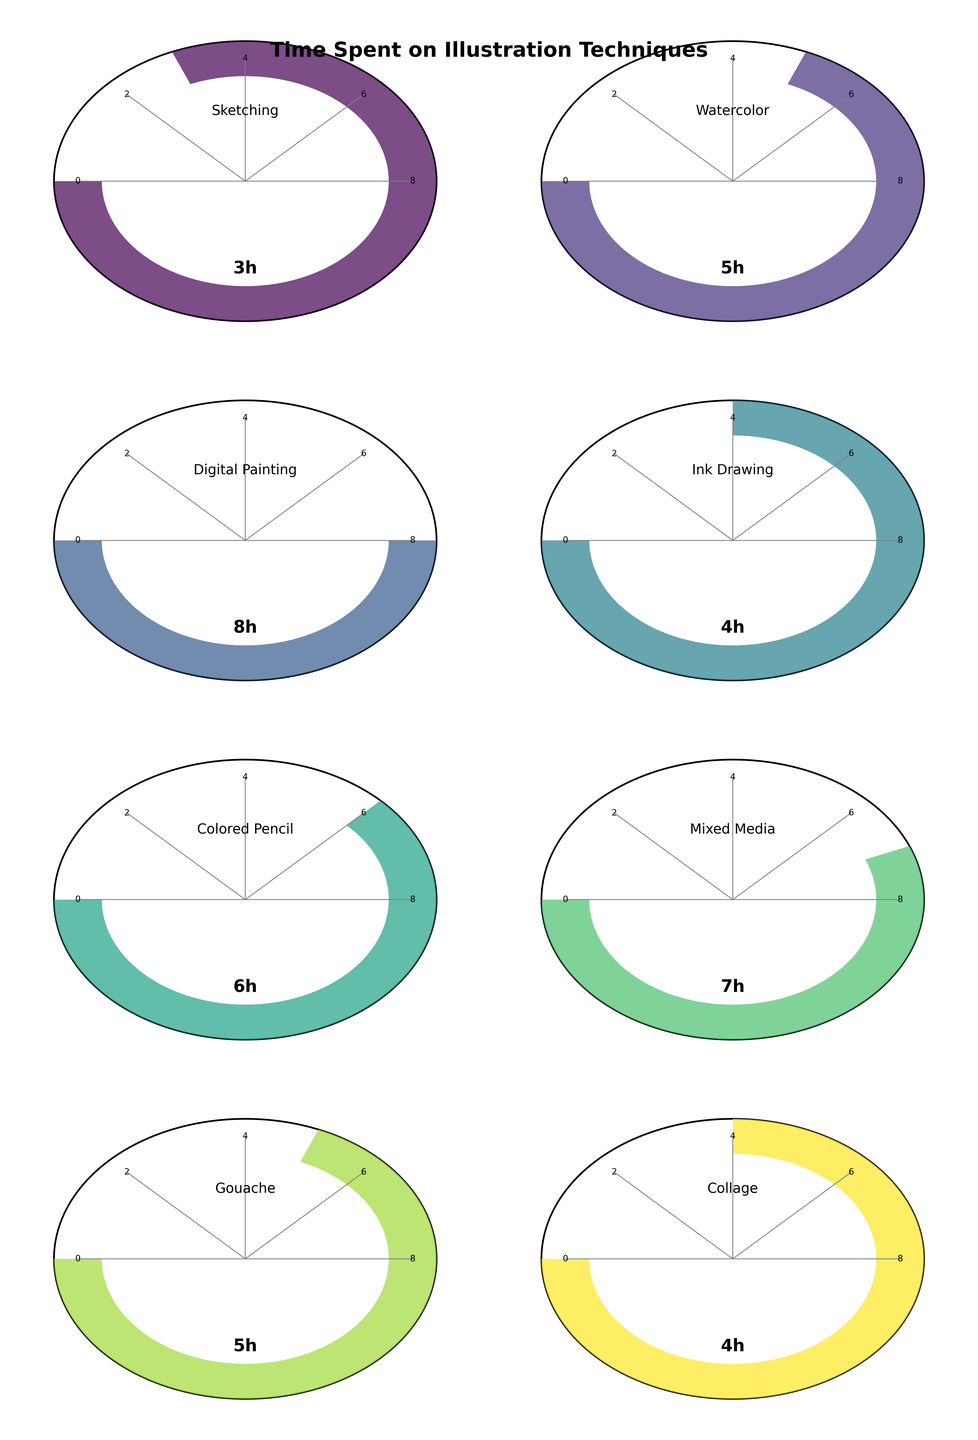What is the title of the chart? The title is displayed at the top of the figure and reads "Time Spent on Illustration Techniques."
Answer: Time Spent on Illustration Techniques How many techniques are represented in the figure? The figure consists of 8 gauge charts, each corresponding to a different illustration technique.
Answer: 8 Which technique took the most time? By looking at the gauge charts, the "Digital Painting" section has the highest value, registering 8 hours.
Answer: Digital Painting Which technique took 5 hours to complete? There are two gauge charts showing 5 hours: "Watercolor" and "Gouache."
Answer: Watercolor and Gouache How does the time spent on "Sketching" compare to "Colored Pencil"? "Sketching" took 3 hours, while "Colored Pencil" took 6 hours. Since 3 is less than 6, "Sketching" took less time.
Answer: Sketching took less time What's the total time spent on "Watercolor" and "Ink Drawing"? The "Watercolor" chart shows 5 hours, and the "Ink Drawing" chart shows 4 hours. Adding these gives 5 + 4 = 9 hours.
Answer: 9 hours Is there any technique that took exactly 4 hours? Yes, the "Ink Drawing" and "Collage" techniques both took 4 hours as shown in their respective gauge charts.
Answer: Ink Drawing and Collage What's the difference in hours spent between "Mixed Media" and "Gouache"? "Mixed Media" took 7 hours, and "Gouache" took 5 hours. The difference is 7 - 5 = 2 hours.
Answer: 2 hours What is the average time spent on all techniques? Sum the hours (3+5+8+4+6+7+5+4 = 42) and divide by the number of techniques (8). The average time is 42 / 8 = 5.25 hours.
Answer: 5.25 hours Which techniques required less than 5 hours? The gauge charts for "Sketching" (3 hours), "Ink Drawing" (4 hours), and "Collage" (4 hours) all show that these techniques took less than 5 hours.
Answer: Sketching, Ink Drawing, and Collage 